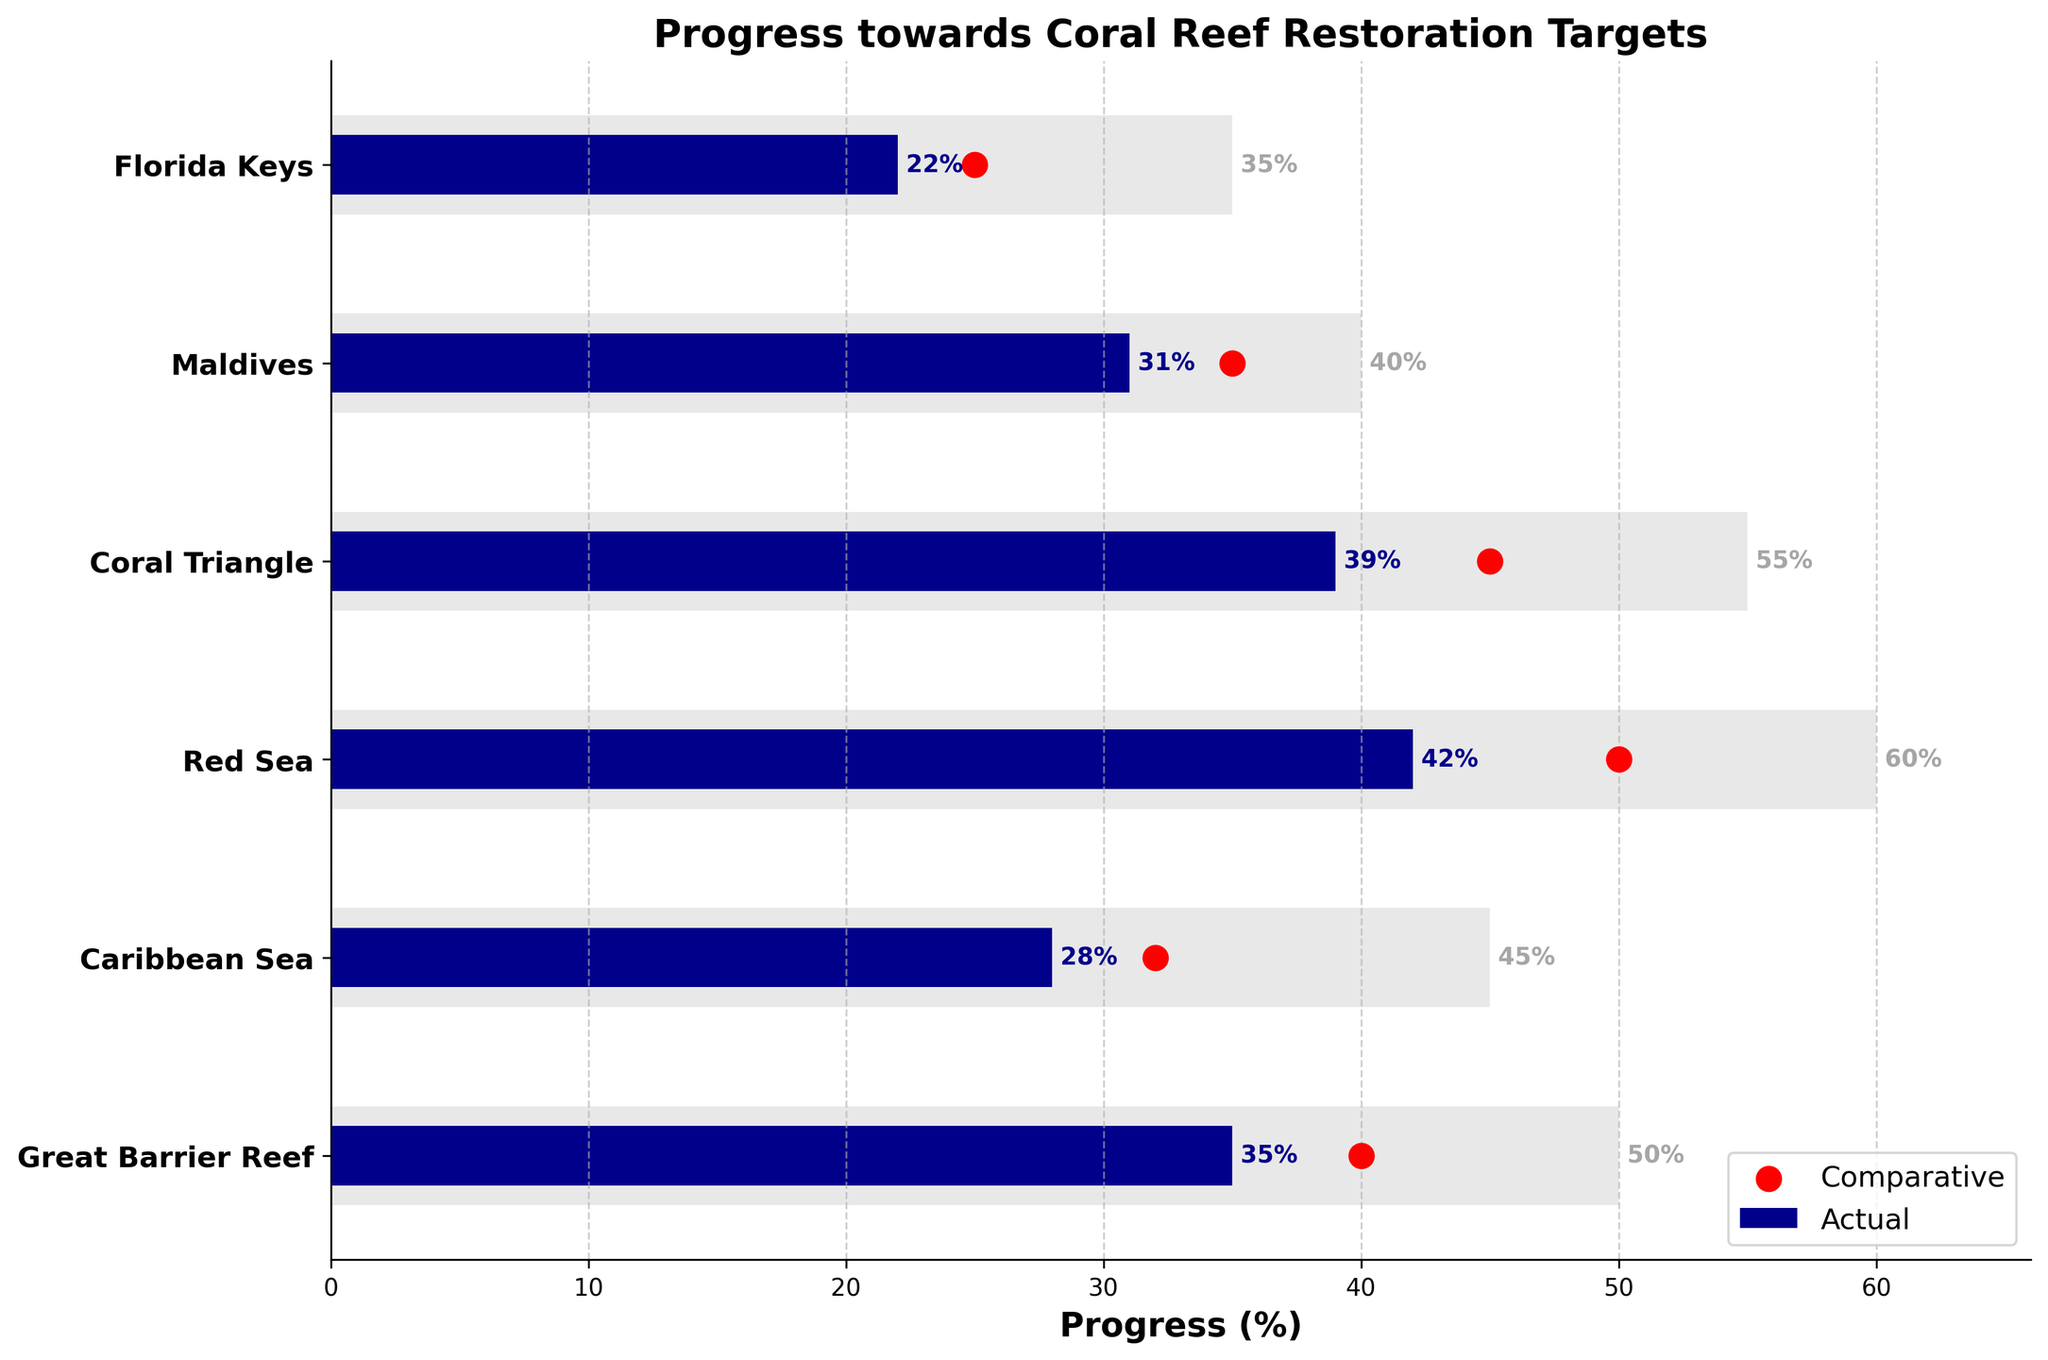How many regions are displayed in the chart? The chart has one bar for each region, and counting how many bars there are will give the number of regions. There are six bars, indicating six regions are displayed.
Answer: Six What is the title of the chart? The title of the chart is displayed at the top of the figure, usually in larger or bold font.
Answer: Progress towards Coral Reef Restoration Targets Which region has achieved the highest actual progress? Look at the 'Actual' values represented by the blue bars. The region with the longest blue bar has the highest actual progress.
Answer: Red Sea What is the actual progress of the Maldives? Locate the Maldives on the Y-axis, then read the length of the blue bar representing actual progress next to it, which is labeled with its value.
Answer: 31% What is the gap between the target and actual progress in the Florida Keys? Find the Florida Keys' target value, then subtract the actual progress value from this target value (35 - 22).
Answer: 13% Which region is closest to the comparative value? Compare the actual values marked by red dots with the comparative values. The region where the blue bar end (actual) is closest to the red dot represents the closest match.
Answer: Maldives Is the actual progress in the Caribbean Sea higher or lower than the comparative progress in the same region? Compare the position of the end of the blue bar (actual) with the red dot (comparative) for the Caribbean Sea. The actual progress is 28%, and comparative is 32%.
Answer: Lower What is the total target progress for all regions combined? Sum the 'Target' values: 50 (Great Barrier Reef) + 45 (Caribbean Sea) + 60 (Red Sea) + 55 (Coral Triangle) + 40 (Maldives) + 35 (Florida Keys).
Answer: 285% Which region has the smallest difference between actual and comparative progress? Calculate the difference between actual and comparative values for all regions and find the smallest: i.e., 31% - 35% for Maldives, 22% - 25% for Florida Keys, etc. Maldives has a difference of 4%.
Answer: Maldives How does the actual progress in the Great Barrier Reef compare to its target? Compare the length of the blue bar (actual, 35%) with the grey bar (target, 50%) for the Great Barrier Reef to see if the actual value is less and by how much.
Answer: It is 15% less 